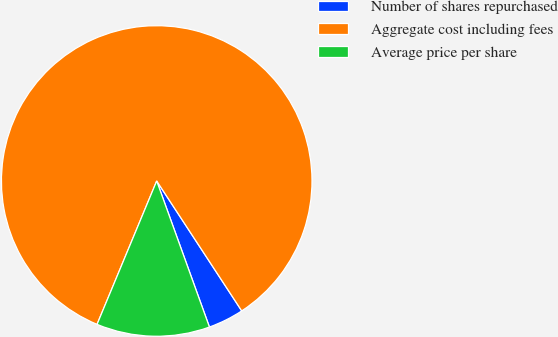<chart> <loc_0><loc_0><loc_500><loc_500><pie_chart><fcel>Number of shares repurchased<fcel>Aggregate cost including fees<fcel>Average price per share<nl><fcel>3.71%<fcel>84.51%<fcel>11.79%<nl></chart> 